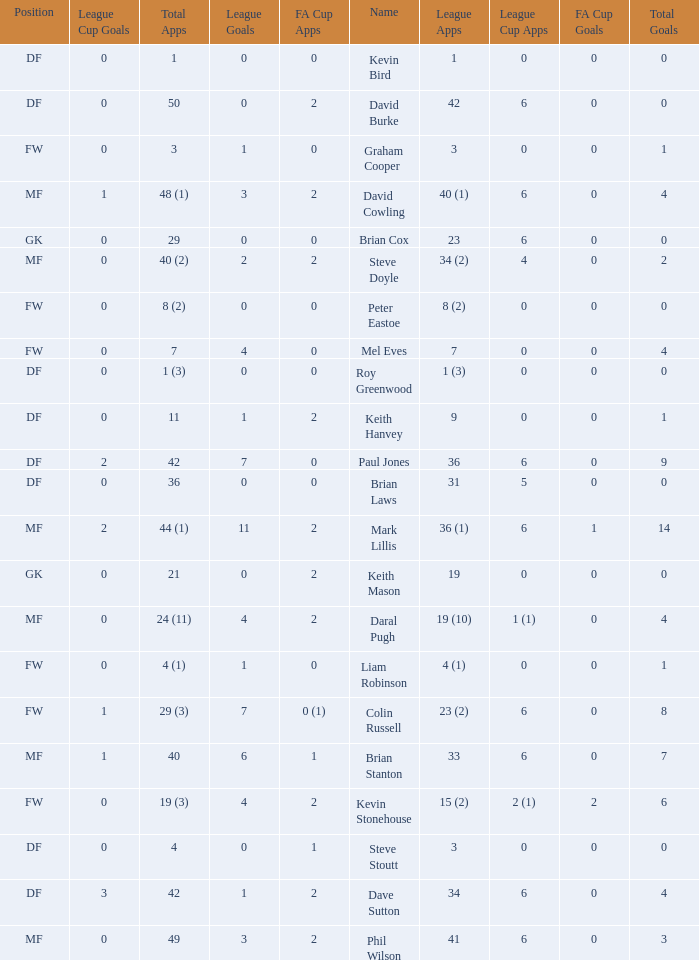What is the most total goals for a player having 0 FA Cup goals and 41 League appearances? 3.0. 